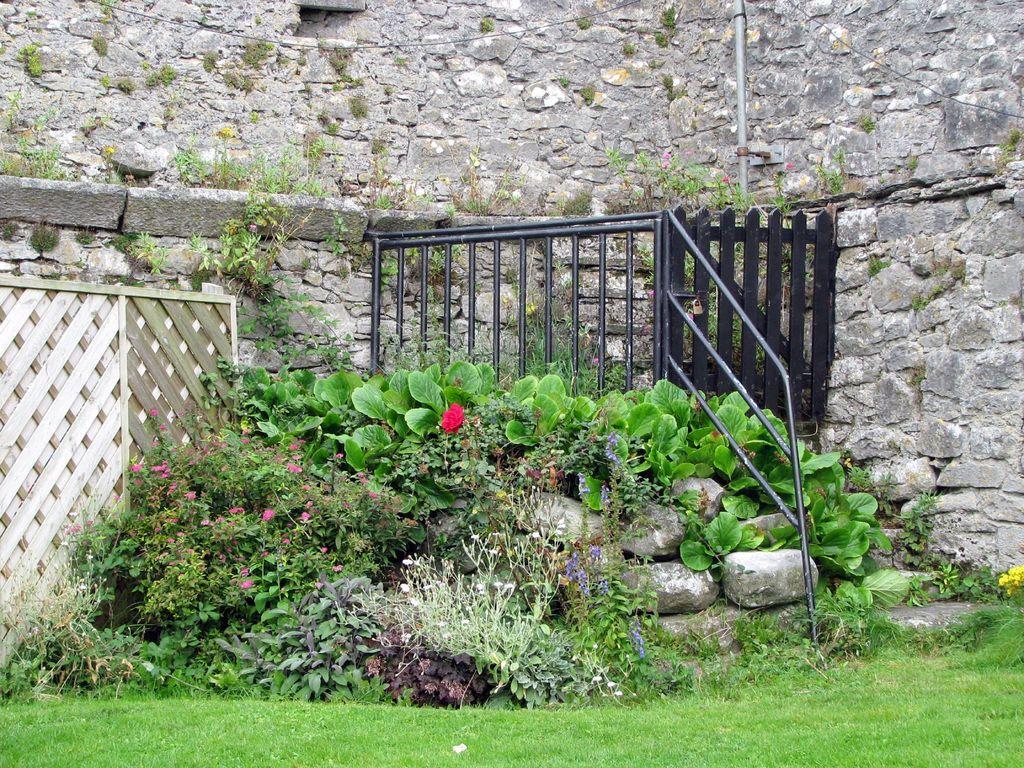How would you summarize this image in a sentence or two? This picture shows few plants and we see a metal fence and a gate and we see grass on the ground and a building. 